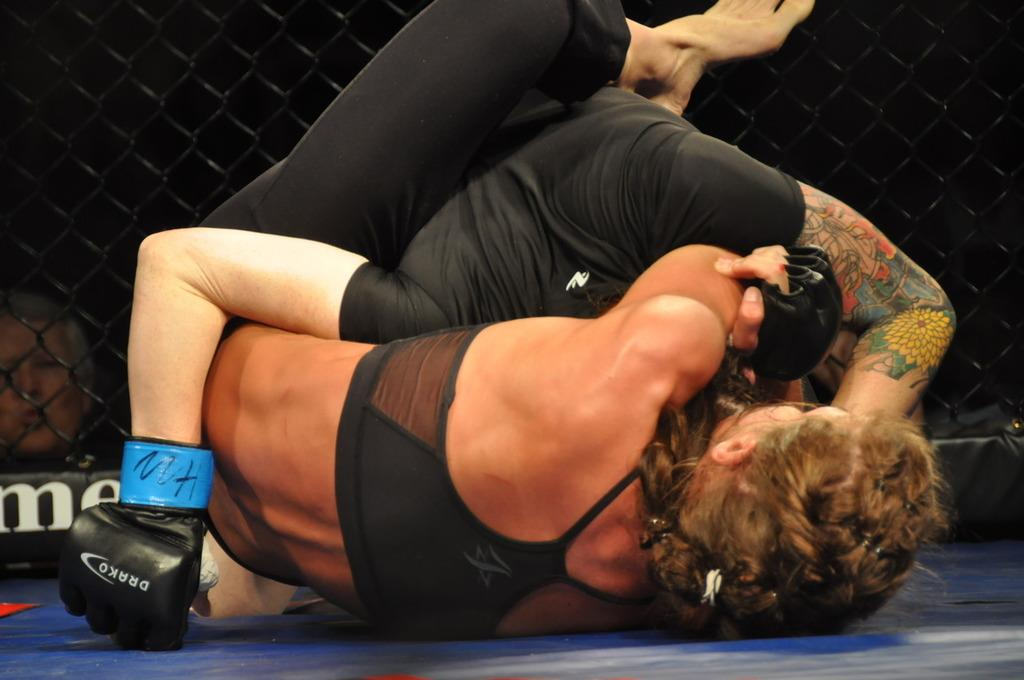<image>
Render a clear and concise summary of the photo. Two people are wrestling while wearing Drako gloves. 